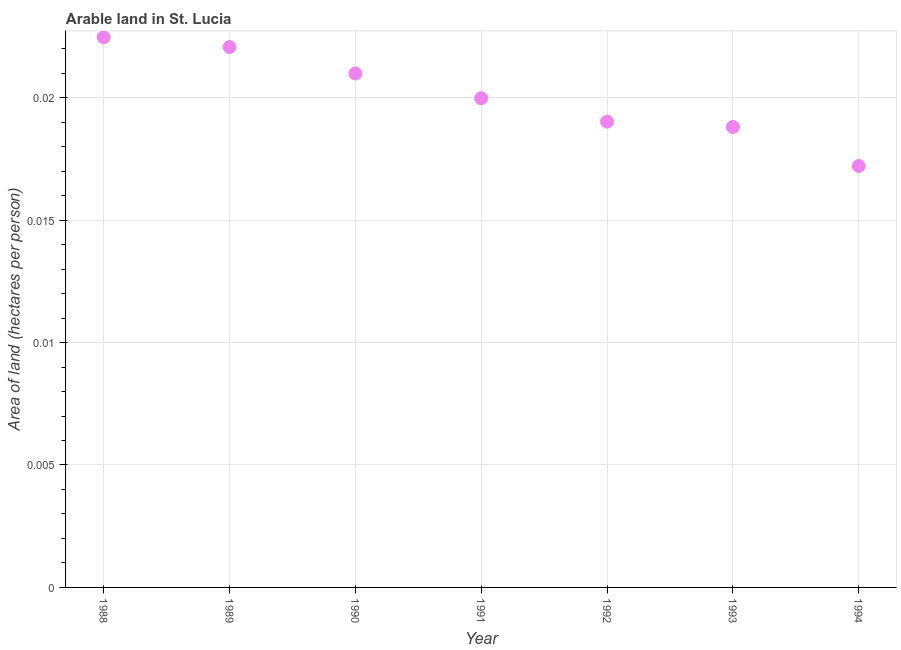What is the area of arable land in 1992?
Your answer should be very brief. 0.02. Across all years, what is the maximum area of arable land?
Your response must be concise. 0.02. Across all years, what is the minimum area of arable land?
Make the answer very short. 0.02. In which year was the area of arable land maximum?
Ensure brevity in your answer.  1988. What is the sum of the area of arable land?
Ensure brevity in your answer.  0.14. What is the difference between the area of arable land in 1989 and 1993?
Make the answer very short. 0. What is the average area of arable land per year?
Provide a short and direct response. 0.02. What is the median area of arable land?
Provide a succinct answer. 0.02. In how many years, is the area of arable land greater than 0.016 hectares per person?
Make the answer very short. 7. Do a majority of the years between 1991 and 1988 (inclusive) have area of arable land greater than 0.018 hectares per person?
Provide a short and direct response. Yes. What is the ratio of the area of arable land in 1988 to that in 1994?
Your answer should be compact. 1.31. What is the difference between the highest and the second highest area of arable land?
Give a very brief answer. 0. What is the difference between the highest and the lowest area of arable land?
Ensure brevity in your answer.  0.01. Does the area of arable land monotonically increase over the years?
Your answer should be very brief. No. What is the difference between two consecutive major ticks on the Y-axis?
Ensure brevity in your answer.  0.01. Does the graph contain any zero values?
Make the answer very short. No. Does the graph contain grids?
Provide a succinct answer. Yes. What is the title of the graph?
Ensure brevity in your answer.  Arable land in St. Lucia. What is the label or title of the Y-axis?
Offer a very short reply. Area of land (hectares per person). What is the Area of land (hectares per person) in 1988?
Offer a terse response. 0.02. What is the Area of land (hectares per person) in 1989?
Make the answer very short. 0.02. What is the Area of land (hectares per person) in 1990?
Keep it short and to the point. 0.02. What is the Area of land (hectares per person) in 1991?
Offer a terse response. 0.02. What is the Area of land (hectares per person) in 1992?
Provide a short and direct response. 0.02. What is the Area of land (hectares per person) in 1993?
Provide a short and direct response. 0.02. What is the Area of land (hectares per person) in 1994?
Offer a terse response. 0.02. What is the difference between the Area of land (hectares per person) in 1988 and 1989?
Ensure brevity in your answer.  0. What is the difference between the Area of land (hectares per person) in 1988 and 1990?
Your response must be concise. 0. What is the difference between the Area of land (hectares per person) in 1988 and 1991?
Make the answer very short. 0. What is the difference between the Area of land (hectares per person) in 1988 and 1992?
Your response must be concise. 0. What is the difference between the Area of land (hectares per person) in 1988 and 1993?
Your response must be concise. 0. What is the difference between the Area of land (hectares per person) in 1988 and 1994?
Give a very brief answer. 0.01. What is the difference between the Area of land (hectares per person) in 1989 and 1990?
Offer a terse response. 0. What is the difference between the Area of land (hectares per person) in 1989 and 1991?
Your response must be concise. 0. What is the difference between the Area of land (hectares per person) in 1989 and 1992?
Keep it short and to the point. 0. What is the difference between the Area of land (hectares per person) in 1989 and 1993?
Your answer should be very brief. 0. What is the difference between the Area of land (hectares per person) in 1989 and 1994?
Keep it short and to the point. 0. What is the difference between the Area of land (hectares per person) in 1990 and 1991?
Ensure brevity in your answer.  0. What is the difference between the Area of land (hectares per person) in 1990 and 1992?
Your response must be concise. 0. What is the difference between the Area of land (hectares per person) in 1990 and 1993?
Give a very brief answer. 0. What is the difference between the Area of land (hectares per person) in 1990 and 1994?
Offer a terse response. 0. What is the difference between the Area of land (hectares per person) in 1991 and 1992?
Give a very brief answer. 0. What is the difference between the Area of land (hectares per person) in 1991 and 1993?
Keep it short and to the point. 0. What is the difference between the Area of land (hectares per person) in 1991 and 1994?
Give a very brief answer. 0. What is the difference between the Area of land (hectares per person) in 1992 and 1993?
Ensure brevity in your answer.  0. What is the difference between the Area of land (hectares per person) in 1992 and 1994?
Give a very brief answer. 0. What is the difference between the Area of land (hectares per person) in 1993 and 1994?
Your response must be concise. 0. What is the ratio of the Area of land (hectares per person) in 1988 to that in 1990?
Your response must be concise. 1.07. What is the ratio of the Area of land (hectares per person) in 1988 to that in 1991?
Ensure brevity in your answer.  1.12. What is the ratio of the Area of land (hectares per person) in 1988 to that in 1992?
Ensure brevity in your answer.  1.18. What is the ratio of the Area of land (hectares per person) in 1988 to that in 1993?
Offer a very short reply. 1.2. What is the ratio of the Area of land (hectares per person) in 1988 to that in 1994?
Your answer should be compact. 1.3. What is the ratio of the Area of land (hectares per person) in 1989 to that in 1990?
Ensure brevity in your answer.  1.05. What is the ratio of the Area of land (hectares per person) in 1989 to that in 1991?
Your answer should be very brief. 1.1. What is the ratio of the Area of land (hectares per person) in 1989 to that in 1992?
Your answer should be very brief. 1.16. What is the ratio of the Area of land (hectares per person) in 1989 to that in 1993?
Your answer should be compact. 1.17. What is the ratio of the Area of land (hectares per person) in 1989 to that in 1994?
Make the answer very short. 1.28. What is the ratio of the Area of land (hectares per person) in 1990 to that in 1991?
Offer a very short reply. 1.05. What is the ratio of the Area of land (hectares per person) in 1990 to that in 1992?
Offer a terse response. 1.1. What is the ratio of the Area of land (hectares per person) in 1990 to that in 1993?
Offer a very short reply. 1.12. What is the ratio of the Area of land (hectares per person) in 1990 to that in 1994?
Your answer should be compact. 1.22. What is the ratio of the Area of land (hectares per person) in 1991 to that in 1992?
Your answer should be compact. 1.05. What is the ratio of the Area of land (hectares per person) in 1991 to that in 1993?
Offer a very short reply. 1.06. What is the ratio of the Area of land (hectares per person) in 1991 to that in 1994?
Ensure brevity in your answer.  1.16. What is the ratio of the Area of land (hectares per person) in 1992 to that in 1993?
Make the answer very short. 1.01. What is the ratio of the Area of land (hectares per person) in 1992 to that in 1994?
Keep it short and to the point. 1.1. What is the ratio of the Area of land (hectares per person) in 1993 to that in 1994?
Provide a short and direct response. 1.09. 